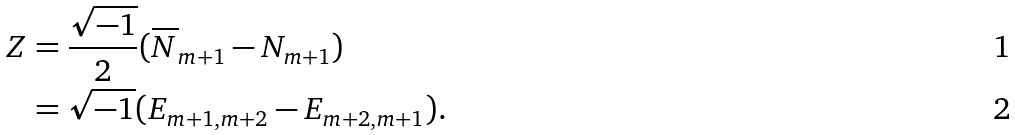Convert formula to latex. <formula><loc_0><loc_0><loc_500><loc_500>Z & = \frac { \sqrt { - 1 } } 2 ( \overline { N } _ { m + 1 } - N _ { m + 1 } ) \\ & = \sqrt { - 1 } ( E _ { m + 1 , m + 2 } - E _ { m + 2 , m + 1 } ) .</formula> 